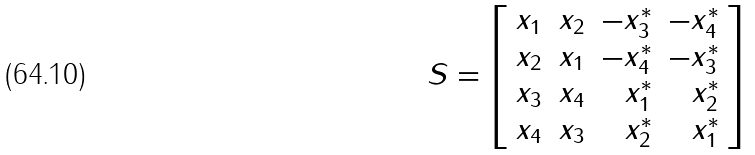<formula> <loc_0><loc_0><loc_500><loc_500>S = \left [ \begin{array} { c c r r } x _ { 1 } & x _ { 2 } & - x _ { 3 } ^ { * } & - x _ { 4 } ^ { * } \\ x _ { 2 } & x _ { 1 } & - x _ { 4 } ^ { * } & - x _ { 3 } ^ { * } \\ x _ { 3 } & x _ { 4 } & x _ { 1 } ^ { * } & x _ { 2 } ^ { * } \\ x _ { 4 } & x _ { 3 } & x _ { 2 } ^ { * } & x _ { 1 } ^ { * } \end{array} \right ]</formula> 